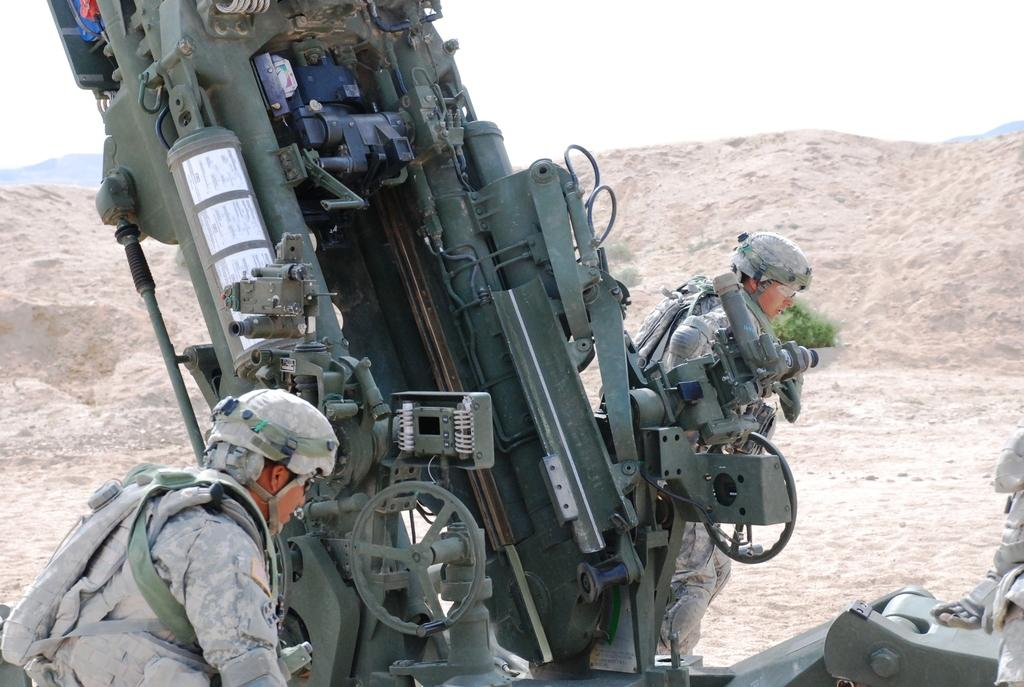How many people are in the image? There are two people in the image. What else can be seen in the image besides the people? There is a vehicle and a mountain visible in the background of the image. What is visible in the sky in the image? The sky is visible in the image. What type of taste does the creator of the image have? There is no information about the creator of the image, so it is impossible to determine their taste preferences. 